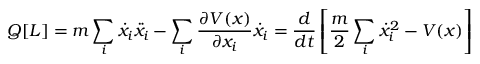<formula> <loc_0><loc_0><loc_500><loc_500>Q [ L ] = m \sum _ { i } { \dot { x } } _ { i } { \ddot { x } } _ { i } - \sum _ { i } { \frac { \partial V ( x ) } { \partial x _ { i } } } { \dot { x } } _ { i } = { \frac { d } { d t } } \left [ { \frac { m } { 2 } } \sum _ { i } { \dot { x } } _ { i } ^ { 2 } - V ( x ) \right ]</formula> 